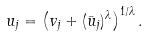Convert formula to latex. <formula><loc_0><loc_0><loc_500><loc_500>u _ { j } = \left ( v _ { j } + ( \bar { u } _ { j } ) ^ { \lambda } \right ) ^ { 1 / \lambda } .</formula> 